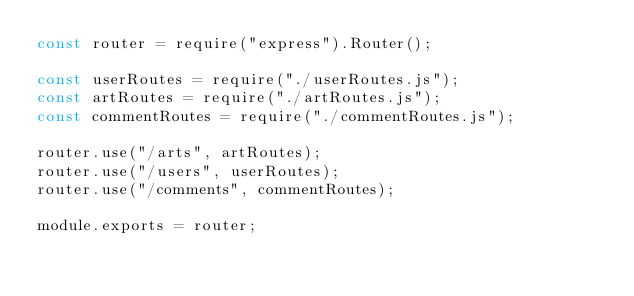Convert code to text. <code><loc_0><loc_0><loc_500><loc_500><_JavaScript_>const router = require("express").Router();

const userRoutes = require("./userRoutes.js");
const artRoutes = require("./artRoutes.js");
const commentRoutes = require("./commentRoutes.js");

router.use("/arts", artRoutes);
router.use("/users", userRoutes);
router.use("/comments", commentRoutes);

module.exports = router;
</code> 